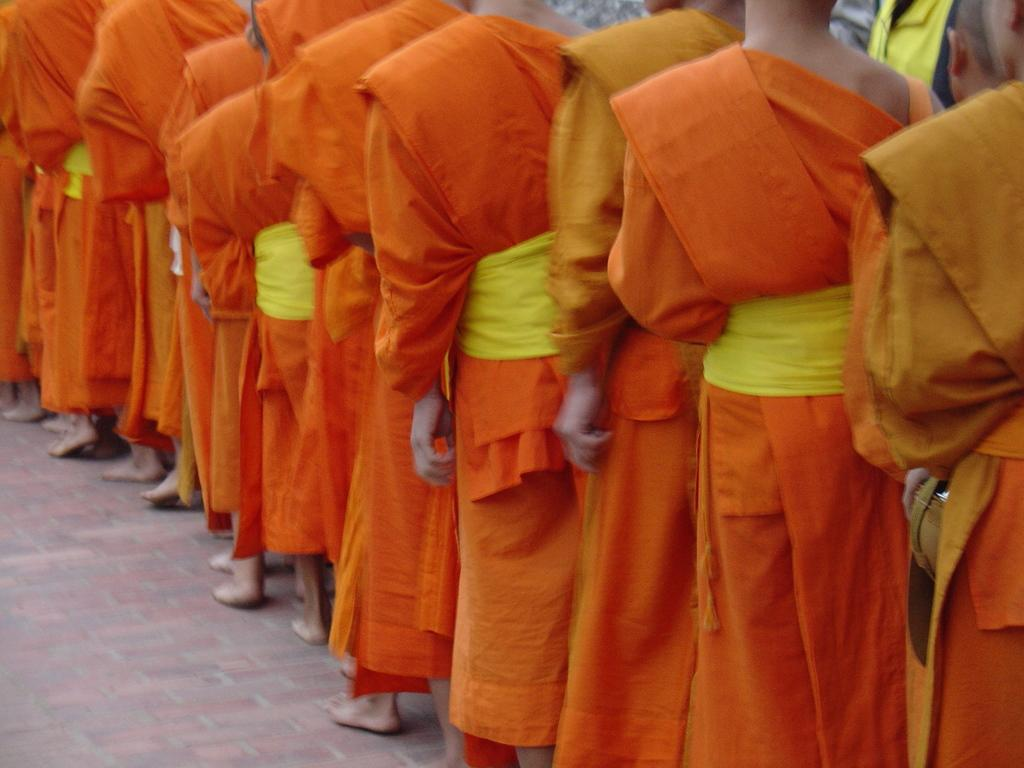What is happening in the image? There are many persons standing in line in the image. Where are the persons standing? The persons are standing on the floor. What color are the dresses of the persons in the image? The persons are wearing orange color dress. What can be inferred about the persons based on their attire? The persons seem to be monks. What type of button can be seen on the swimsuit of the person in the image? There is no swimsuit or button present in the image; the persons are wearing orange color dresses and seem to be monks. 